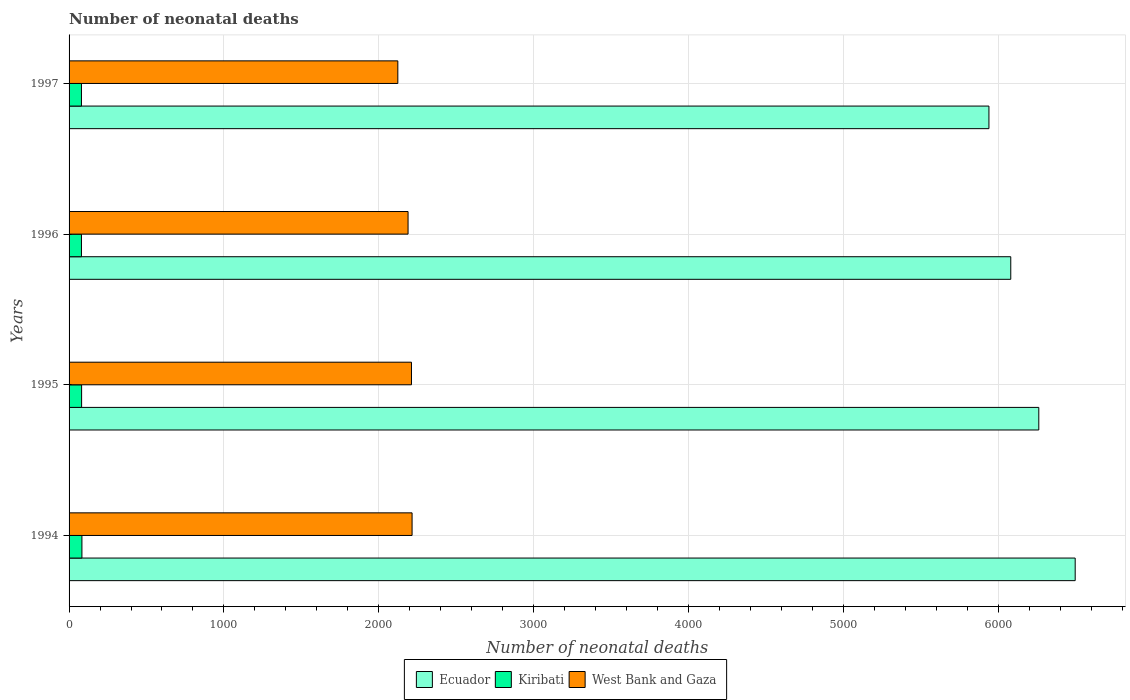How many different coloured bars are there?
Your answer should be compact. 3. Are the number of bars per tick equal to the number of legend labels?
Provide a succinct answer. Yes. In how many cases, is the number of bars for a given year not equal to the number of legend labels?
Provide a short and direct response. 0. What is the number of neonatal deaths in in Kiribati in 1995?
Offer a terse response. 81. Across all years, what is the maximum number of neonatal deaths in in West Bank and Gaza?
Your answer should be compact. 2215. Across all years, what is the minimum number of neonatal deaths in in Ecuador?
Provide a short and direct response. 5940. What is the total number of neonatal deaths in in Kiribati in the graph?
Provide a succinct answer. 324. What is the difference between the number of neonatal deaths in in Ecuador in 1996 and that in 1997?
Ensure brevity in your answer.  141. What is the difference between the number of neonatal deaths in in Ecuador in 1994 and the number of neonatal deaths in in Kiribati in 1996?
Offer a terse response. 6417. What is the average number of neonatal deaths in in Kiribati per year?
Offer a very short reply. 81. In the year 1995, what is the difference between the number of neonatal deaths in in West Bank and Gaza and number of neonatal deaths in in Kiribati?
Offer a very short reply. 2130. In how many years, is the number of neonatal deaths in in Ecuador greater than 1600 ?
Your answer should be compact. 4. What is the ratio of the number of neonatal deaths in in Ecuador in 1994 to that in 1995?
Your response must be concise. 1.04. Is the number of neonatal deaths in in West Bank and Gaza in 1994 less than that in 1997?
Ensure brevity in your answer.  No. What is the difference between the highest and the second highest number of neonatal deaths in in Kiribati?
Your response must be concise. 2. What is the difference between the highest and the lowest number of neonatal deaths in in Kiribati?
Provide a succinct answer. 3. In how many years, is the number of neonatal deaths in in Kiribati greater than the average number of neonatal deaths in in Kiribati taken over all years?
Provide a short and direct response. 1. What does the 2nd bar from the top in 1994 represents?
Ensure brevity in your answer.  Kiribati. What does the 3rd bar from the bottom in 1996 represents?
Your answer should be very brief. West Bank and Gaza. How many years are there in the graph?
Provide a short and direct response. 4. What is the difference between two consecutive major ticks on the X-axis?
Offer a very short reply. 1000. Does the graph contain any zero values?
Your answer should be compact. No. How many legend labels are there?
Provide a short and direct response. 3. What is the title of the graph?
Offer a terse response. Number of neonatal deaths. Does "Macedonia" appear as one of the legend labels in the graph?
Your response must be concise. No. What is the label or title of the X-axis?
Your answer should be compact. Number of neonatal deaths. What is the label or title of the Y-axis?
Your answer should be very brief. Years. What is the Number of neonatal deaths in Ecuador in 1994?
Keep it short and to the point. 6497. What is the Number of neonatal deaths in West Bank and Gaza in 1994?
Keep it short and to the point. 2215. What is the Number of neonatal deaths of Ecuador in 1995?
Offer a very short reply. 6262. What is the Number of neonatal deaths of West Bank and Gaza in 1995?
Your answer should be very brief. 2211. What is the Number of neonatal deaths in Ecuador in 1996?
Provide a succinct answer. 6081. What is the Number of neonatal deaths of West Bank and Gaza in 1996?
Keep it short and to the point. 2189. What is the Number of neonatal deaths of Ecuador in 1997?
Provide a succinct answer. 5940. What is the Number of neonatal deaths in Kiribati in 1997?
Your response must be concise. 80. What is the Number of neonatal deaths of West Bank and Gaza in 1997?
Ensure brevity in your answer.  2123. Across all years, what is the maximum Number of neonatal deaths of Ecuador?
Make the answer very short. 6497. Across all years, what is the maximum Number of neonatal deaths of Kiribati?
Keep it short and to the point. 83. Across all years, what is the maximum Number of neonatal deaths of West Bank and Gaza?
Provide a succinct answer. 2215. Across all years, what is the minimum Number of neonatal deaths of Ecuador?
Make the answer very short. 5940. Across all years, what is the minimum Number of neonatal deaths of West Bank and Gaza?
Your answer should be compact. 2123. What is the total Number of neonatal deaths of Ecuador in the graph?
Provide a succinct answer. 2.48e+04. What is the total Number of neonatal deaths of Kiribati in the graph?
Keep it short and to the point. 324. What is the total Number of neonatal deaths of West Bank and Gaza in the graph?
Keep it short and to the point. 8738. What is the difference between the Number of neonatal deaths of Ecuador in 1994 and that in 1995?
Offer a very short reply. 235. What is the difference between the Number of neonatal deaths of Kiribati in 1994 and that in 1995?
Keep it short and to the point. 2. What is the difference between the Number of neonatal deaths of West Bank and Gaza in 1994 and that in 1995?
Keep it short and to the point. 4. What is the difference between the Number of neonatal deaths in Ecuador in 1994 and that in 1996?
Ensure brevity in your answer.  416. What is the difference between the Number of neonatal deaths in Ecuador in 1994 and that in 1997?
Your response must be concise. 557. What is the difference between the Number of neonatal deaths of West Bank and Gaza in 1994 and that in 1997?
Provide a short and direct response. 92. What is the difference between the Number of neonatal deaths in Ecuador in 1995 and that in 1996?
Your answer should be very brief. 181. What is the difference between the Number of neonatal deaths in Kiribati in 1995 and that in 1996?
Provide a short and direct response. 1. What is the difference between the Number of neonatal deaths of West Bank and Gaza in 1995 and that in 1996?
Your answer should be compact. 22. What is the difference between the Number of neonatal deaths of Ecuador in 1995 and that in 1997?
Your answer should be very brief. 322. What is the difference between the Number of neonatal deaths of Kiribati in 1995 and that in 1997?
Provide a short and direct response. 1. What is the difference between the Number of neonatal deaths of Ecuador in 1996 and that in 1997?
Offer a very short reply. 141. What is the difference between the Number of neonatal deaths in Kiribati in 1996 and that in 1997?
Offer a terse response. 0. What is the difference between the Number of neonatal deaths of Ecuador in 1994 and the Number of neonatal deaths of Kiribati in 1995?
Provide a succinct answer. 6416. What is the difference between the Number of neonatal deaths in Ecuador in 1994 and the Number of neonatal deaths in West Bank and Gaza in 1995?
Keep it short and to the point. 4286. What is the difference between the Number of neonatal deaths in Kiribati in 1994 and the Number of neonatal deaths in West Bank and Gaza in 1995?
Provide a short and direct response. -2128. What is the difference between the Number of neonatal deaths of Ecuador in 1994 and the Number of neonatal deaths of Kiribati in 1996?
Offer a very short reply. 6417. What is the difference between the Number of neonatal deaths in Ecuador in 1994 and the Number of neonatal deaths in West Bank and Gaza in 1996?
Offer a terse response. 4308. What is the difference between the Number of neonatal deaths in Kiribati in 1994 and the Number of neonatal deaths in West Bank and Gaza in 1996?
Offer a terse response. -2106. What is the difference between the Number of neonatal deaths in Ecuador in 1994 and the Number of neonatal deaths in Kiribati in 1997?
Provide a short and direct response. 6417. What is the difference between the Number of neonatal deaths in Ecuador in 1994 and the Number of neonatal deaths in West Bank and Gaza in 1997?
Your answer should be very brief. 4374. What is the difference between the Number of neonatal deaths in Kiribati in 1994 and the Number of neonatal deaths in West Bank and Gaza in 1997?
Your answer should be very brief. -2040. What is the difference between the Number of neonatal deaths of Ecuador in 1995 and the Number of neonatal deaths of Kiribati in 1996?
Give a very brief answer. 6182. What is the difference between the Number of neonatal deaths in Ecuador in 1995 and the Number of neonatal deaths in West Bank and Gaza in 1996?
Ensure brevity in your answer.  4073. What is the difference between the Number of neonatal deaths in Kiribati in 1995 and the Number of neonatal deaths in West Bank and Gaza in 1996?
Provide a short and direct response. -2108. What is the difference between the Number of neonatal deaths of Ecuador in 1995 and the Number of neonatal deaths of Kiribati in 1997?
Provide a succinct answer. 6182. What is the difference between the Number of neonatal deaths in Ecuador in 1995 and the Number of neonatal deaths in West Bank and Gaza in 1997?
Provide a short and direct response. 4139. What is the difference between the Number of neonatal deaths in Kiribati in 1995 and the Number of neonatal deaths in West Bank and Gaza in 1997?
Provide a succinct answer. -2042. What is the difference between the Number of neonatal deaths in Ecuador in 1996 and the Number of neonatal deaths in Kiribati in 1997?
Provide a short and direct response. 6001. What is the difference between the Number of neonatal deaths of Ecuador in 1996 and the Number of neonatal deaths of West Bank and Gaza in 1997?
Provide a succinct answer. 3958. What is the difference between the Number of neonatal deaths in Kiribati in 1996 and the Number of neonatal deaths in West Bank and Gaza in 1997?
Provide a succinct answer. -2043. What is the average Number of neonatal deaths in Ecuador per year?
Provide a succinct answer. 6195. What is the average Number of neonatal deaths in Kiribati per year?
Ensure brevity in your answer.  81. What is the average Number of neonatal deaths of West Bank and Gaza per year?
Provide a short and direct response. 2184.5. In the year 1994, what is the difference between the Number of neonatal deaths of Ecuador and Number of neonatal deaths of Kiribati?
Offer a terse response. 6414. In the year 1994, what is the difference between the Number of neonatal deaths of Ecuador and Number of neonatal deaths of West Bank and Gaza?
Offer a terse response. 4282. In the year 1994, what is the difference between the Number of neonatal deaths of Kiribati and Number of neonatal deaths of West Bank and Gaza?
Offer a very short reply. -2132. In the year 1995, what is the difference between the Number of neonatal deaths of Ecuador and Number of neonatal deaths of Kiribati?
Keep it short and to the point. 6181. In the year 1995, what is the difference between the Number of neonatal deaths of Ecuador and Number of neonatal deaths of West Bank and Gaza?
Ensure brevity in your answer.  4051. In the year 1995, what is the difference between the Number of neonatal deaths of Kiribati and Number of neonatal deaths of West Bank and Gaza?
Your answer should be compact. -2130. In the year 1996, what is the difference between the Number of neonatal deaths of Ecuador and Number of neonatal deaths of Kiribati?
Ensure brevity in your answer.  6001. In the year 1996, what is the difference between the Number of neonatal deaths of Ecuador and Number of neonatal deaths of West Bank and Gaza?
Ensure brevity in your answer.  3892. In the year 1996, what is the difference between the Number of neonatal deaths of Kiribati and Number of neonatal deaths of West Bank and Gaza?
Make the answer very short. -2109. In the year 1997, what is the difference between the Number of neonatal deaths in Ecuador and Number of neonatal deaths in Kiribati?
Keep it short and to the point. 5860. In the year 1997, what is the difference between the Number of neonatal deaths of Ecuador and Number of neonatal deaths of West Bank and Gaza?
Provide a short and direct response. 3817. In the year 1997, what is the difference between the Number of neonatal deaths in Kiribati and Number of neonatal deaths in West Bank and Gaza?
Provide a short and direct response. -2043. What is the ratio of the Number of neonatal deaths in Ecuador in 1994 to that in 1995?
Provide a short and direct response. 1.04. What is the ratio of the Number of neonatal deaths of Kiribati in 1994 to that in 1995?
Your answer should be compact. 1.02. What is the ratio of the Number of neonatal deaths of West Bank and Gaza in 1994 to that in 1995?
Your answer should be very brief. 1. What is the ratio of the Number of neonatal deaths in Ecuador in 1994 to that in 1996?
Ensure brevity in your answer.  1.07. What is the ratio of the Number of neonatal deaths in Kiribati in 1994 to that in 1996?
Your answer should be compact. 1.04. What is the ratio of the Number of neonatal deaths in West Bank and Gaza in 1994 to that in 1996?
Your answer should be compact. 1.01. What is the ratio of the Number of neonatal deaths in Ecuador in 1994 to that in 1997?
Offer a very short reply. 1.09. What is the ratio of the Number of neonatal deaths in Kiribati in 1994 to that in 1997?
Provide a short and direct response. 1.04. What is the ratio of the Number of neonatal deaths of West Bank and Gaza in 1994 to that in 1997?
Make the answer very short. 1.04. What is the ratio of the Number of neonatal deaths of Ecuador in 1995 to that in 1996?
Keep it short and to the point. 1.03. What is the ratio of the Number of neonatal deaths of Kiribati in 1995 to that in 1996?
Your answer should be very brief. 1.01. What is the ratio of the Number of neonatal deaths in Ecuador in 1995 to that in 1997?
Offer a very short reply. 1.05. What is the ratio of the Number of neonatal deaths in Kiribati in 1995 to that in 1997?
Make the answer very short. 1.01. What is the ratio of the Number of neonatal deaths in West Bank and Gaza in 1995 to that in 1997?
Offer a very short reply. 1.04. What is the ratio of the Number of neonatal deaths of Ecuador in 1996 to that in 1997?
Your answer should be very brief. 1.02. What is the ratio of the Number of neonatal deaths of West Bank and Gaza in 1996 to that in 1997?
Make the answer very short. 1.03. What is the difference between the highest and the second highest Number of neonatal deaths of Ecuador?
Give a very brief answer. 235. What is the difference between the highest and the lowest Number of neonatal deaths in Ecuador?
Offer a terse response. 557. What is the difference between the highest and the lowest Number of neonatal deaths in Kiribati?
Ensure brevity in your answer.  3. What is the difference between the highest and the lowest Number of neonatal deaths in West Bank and Gaza?
Offer a very short reply. 92. 